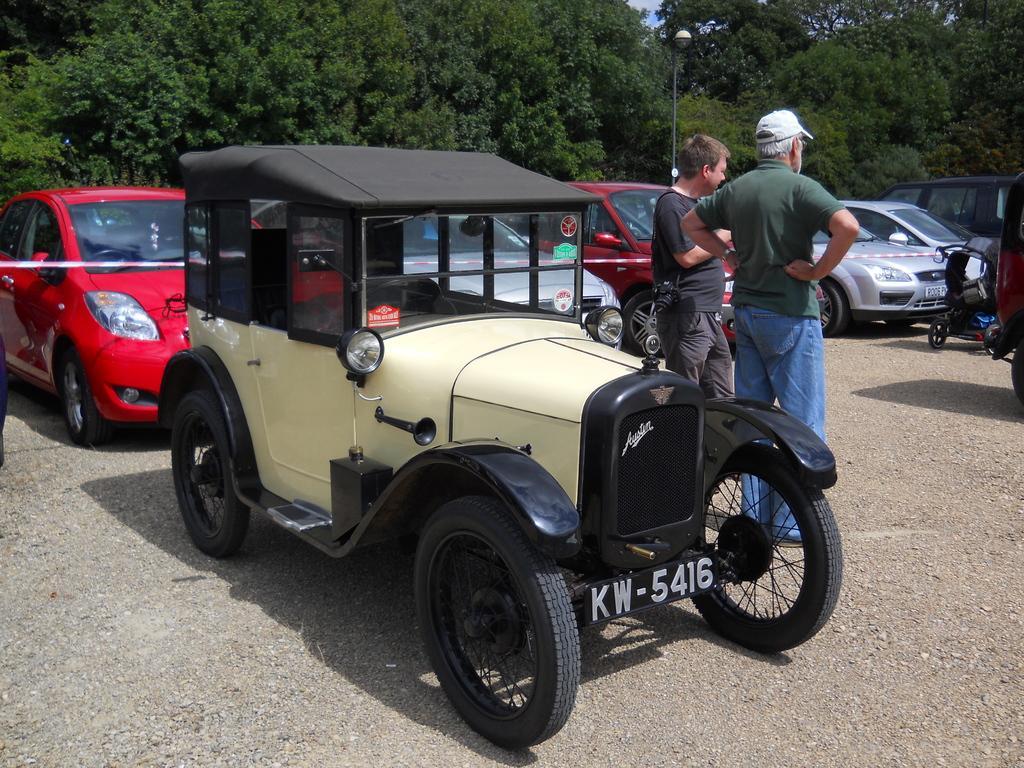Describe this image in one or two sentences. In this picture there is a jeep in the center of the image and there are cars behind it, there are two men on the right side of the image and, there is a pole and trees at the top side of the image. 